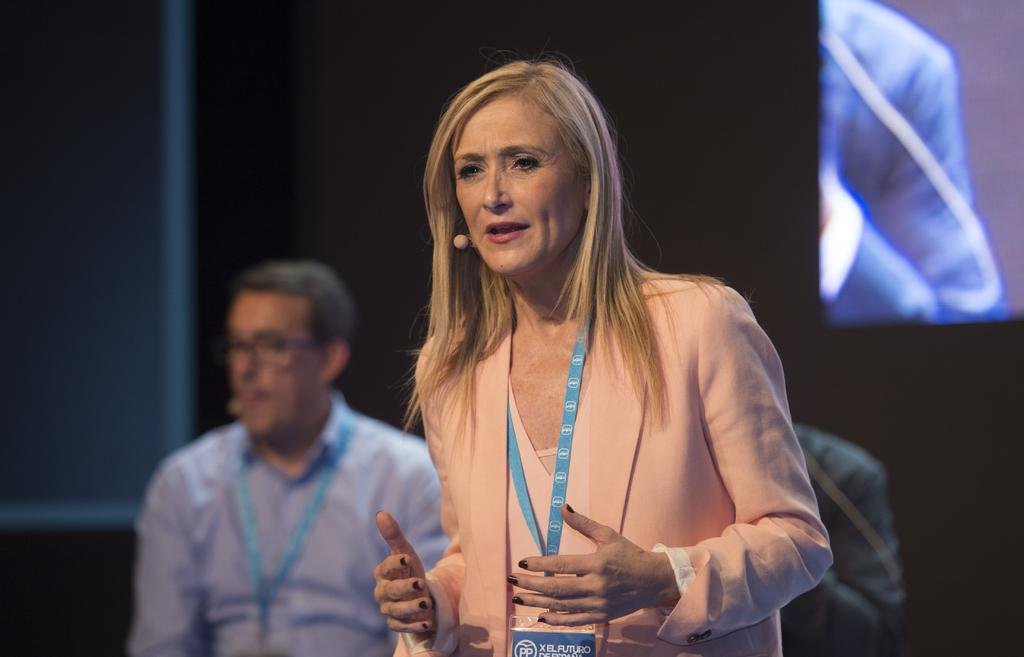How many people are in the image? There are three persons standing in the center of the image. What can be seen in the background of the image? There is a wall and a screen in the background of the image. What type of watch is the person on the left wearing in the image? There is no watch visible on any of the persons in the image. 